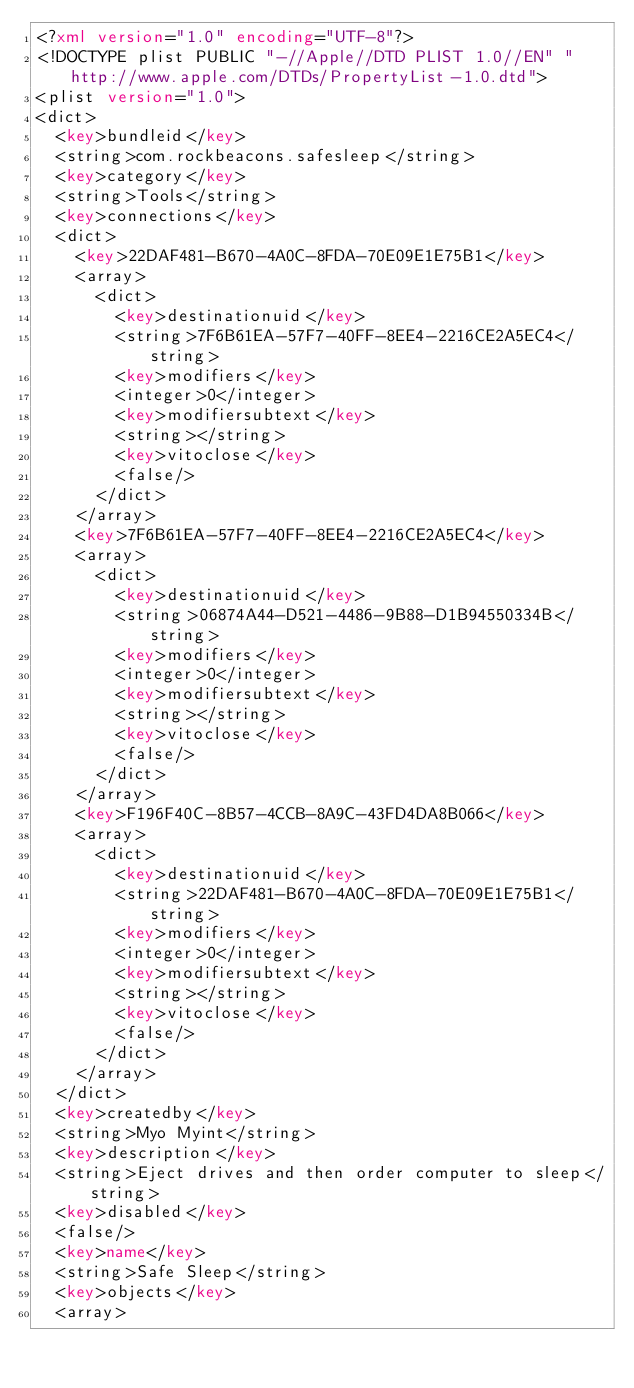Convert code to text. <code><loc_0><loc_0><loc_500><loc_500><_XML_><?xml version="1.0" encoding="UTF-8"?>
<!DOCTYPE plist PUBLIC "-//Apple//DTD PLIST 1.0//EN" "http://www.apple.com/DTDs/PropertyList-1.0.dtd">
<plist version="1.0">
<dict>
	<key>bundleid</key>
	<string>com.rockbeacons.safesleep</string>
	<key>category</key>
	<string>Tools</string>
	<key>connections</key>
	<dict>
		<key>22DAF481-B670-4A0C-8FDA-70E09E1E75B1</key>
		<array>
			<dict>
				<key>destinationuid</key>
				<string>7F6B61EA-57F7-40FF-8EE4-2216CE2A5EC4</string>
				<key>modifiers</key>
				<integer>0</integer>
				<key>modifiersubtext</key>
				<string></string>
				<key>vitoclose</key>
				<false/>
			</dict>
		</array>
		<key>7F6B61EA-57F7-40FF-8EE4-2216CE2A5EC4</key>
		<array>
			<dict>
				<key>destinationuid</key>
				<string>06874A44-D521-4486-9B88-D1B94550334B</string>
				<key>modifiers</key>
				<integer>0</integer>
				<key>modifiersubtext</key>
				<string></string>
				<key>vitoclose</key>
				<false/>
			</dict>
		</array>
		<key>F196F40C-8B57-4CCB-8A9C-43FD4DA8B066</key>
		<array>
			<dict>
				<key>destinationuid</key>
				<string>22DAF481-B670-4A0C-8FDA-70E09E1E75B1</string>
				<key>modifiers</key>
				<integer>0</integer>
				<key>modifiersubtext</key>
				<string></string>
				<key>vitoclose</key>
				<false/>
			</dict>
		</array>
	</dict>
	<key>createdby</key>
	<string>Myo Myint</string>
	<key>description</key>
	<string>Eject drives and then order computer to sleep</string>
	<key>disabled</key>
	<false/>
	<key>name</key>
	<string>Safe Sleep</string>
	<key>objects</key>
	<array></code> 